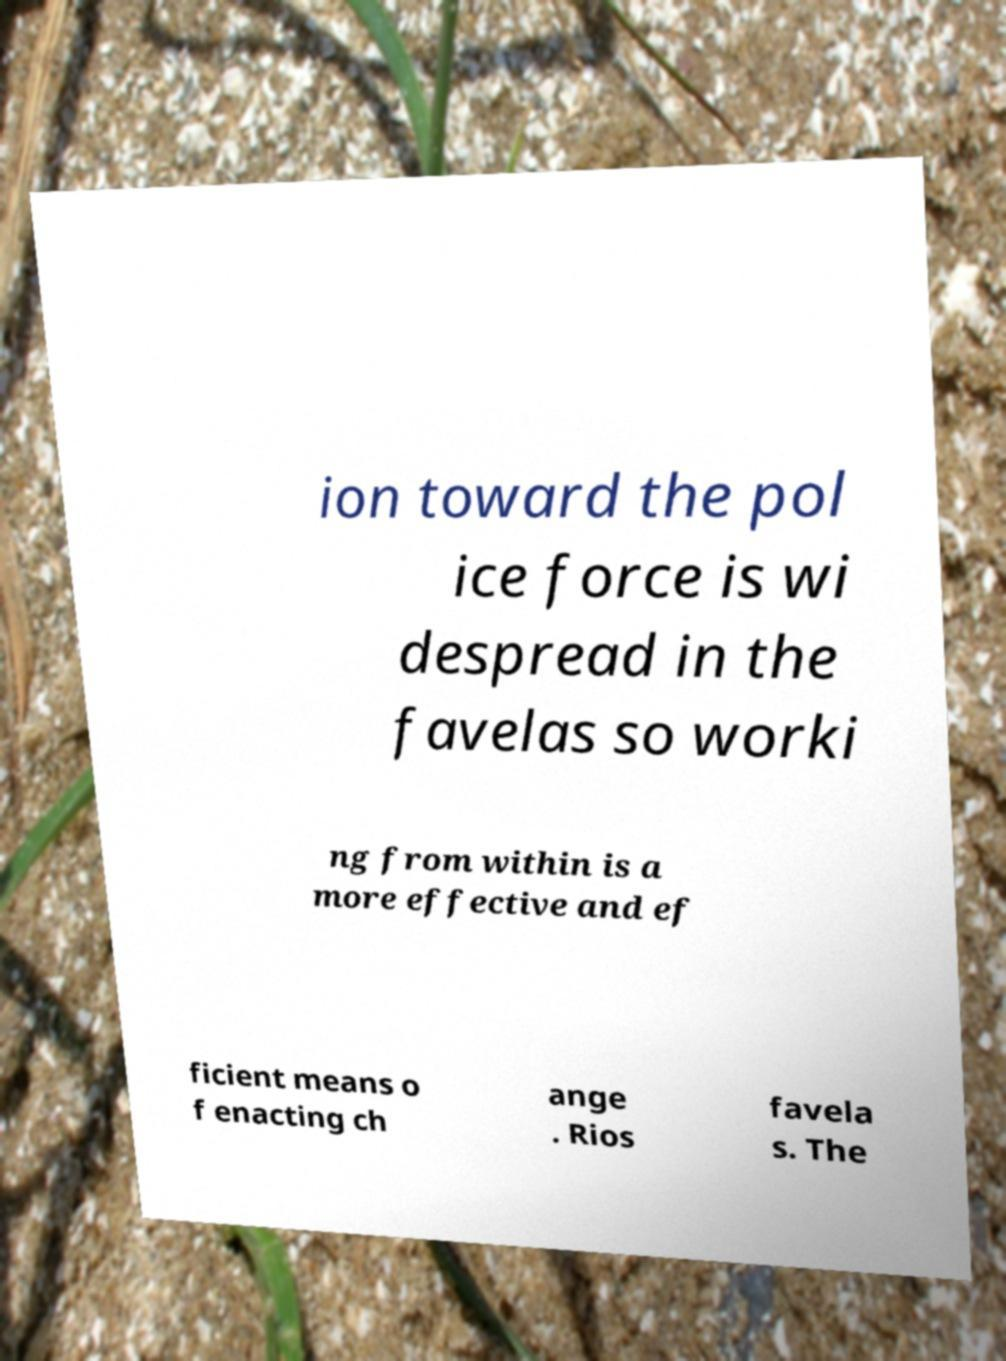I need the written content from this picture converted into text. Can you do that? ion toward the pol ice force is wi despread in the favelas so worki ng from within is a more effective and ef ficient means o f enacting ch ange . Rios favela s. The 